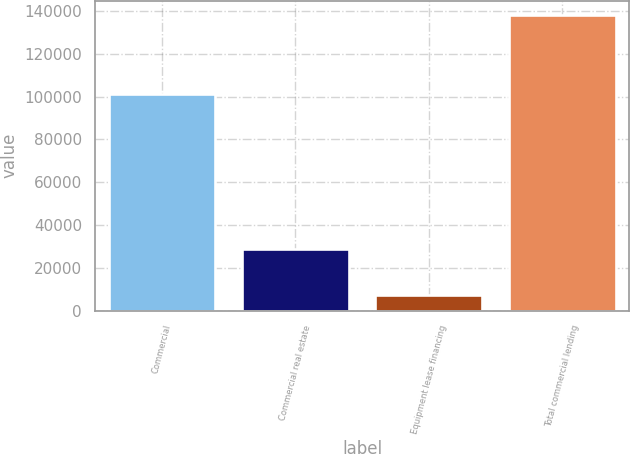Convert chart. <chart><loc_0><loc_0><loc_500><loc_500><bar_chart><fcel>Commercial<fcel>Commercial real estate<fcel>Equipment lease financing<fcel>Total commercial lending<nl><fcel>101364<fcel>29010<fcel>7581<fcel>137955<nl></chart> 